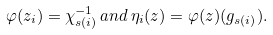<formula> <loc_0><loc_0><loc_500><loc_500>\varphi ( z _ { i } ) = \chi ^ { - 1 } _ { s ( i ) } \, a n d \, \eta _ { i } ( z ) = \varphi ( z ) ( g _ { s ( i ) } ) .</formula> 